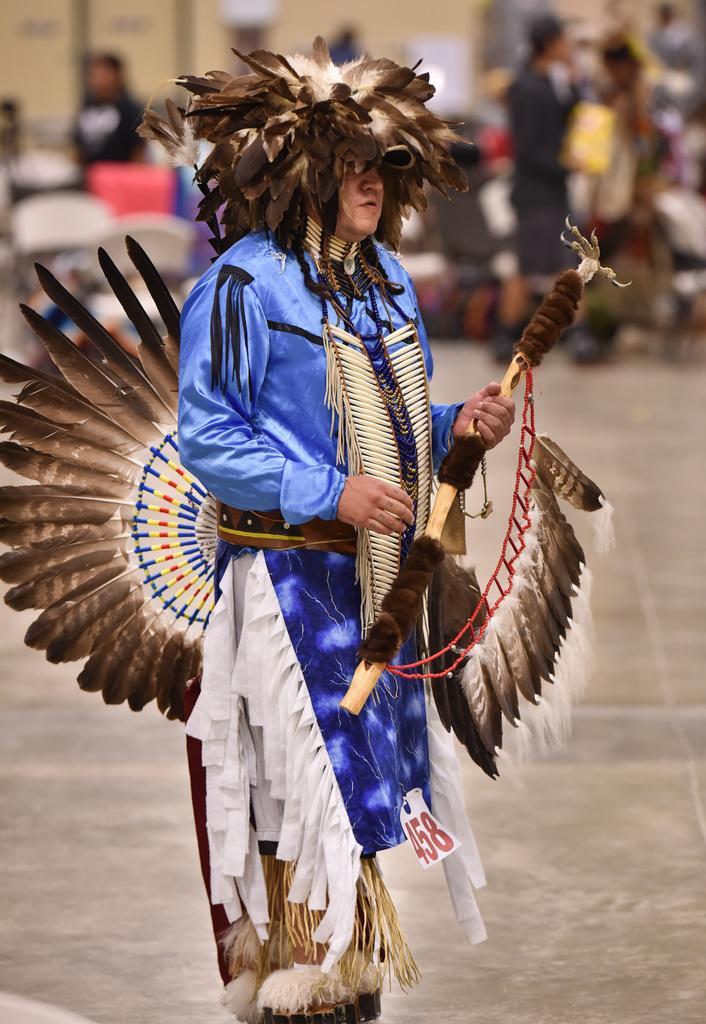Please provide a concise description of this image. In the picture we can see a person standing with different costumes and holding a stick with some feathers to it, and in the background also we can see some people standing on the path. 